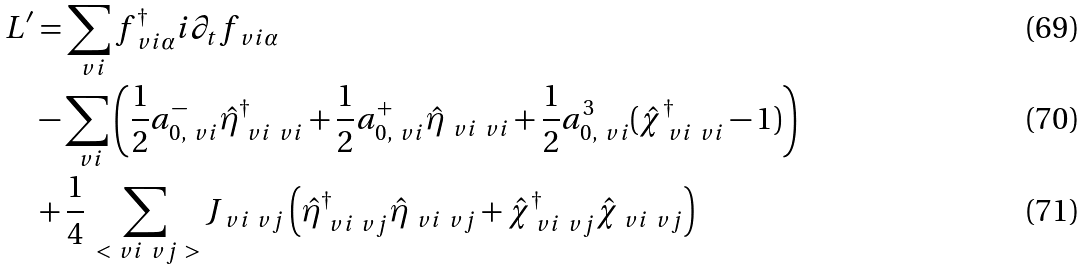Convert formula to latex. <formula><loc_0><loc_0><loc_500><loc_500>L ^ { \prime } & = \sum _ { \ v i } f _ { \ v i \alpha } ^ { \dagger } i \partial _ { t } f _ { \ v i \alpha } \\ & - \sum _ { \ v i } \left ( \frac { 1 } { 2 } a _ { 0 , \ v i } ^ { - } \hat { \eta } _ { \ v i \ v i } ^ { \dagger } + \frac { 1 } { 2 } a _ { 0 , \ v i } ^ { + } \hat { \eta } _ { \ v i \ v i } + \frac { 1 } { 2 } a _ { 0 , \ v i } ^ { 3 } ( \hat { \chi } _ { \ v i \ v i } ^ { \dagger } - 1 ) \right ) \\ & + \frac { 1 } { 4 } \sum _ { \ < \ v i \ v j \ > } J _ { \ v i \ v j } \left ( \hat { \eta } _ { \ v i \ v j } ^ { \dagger } \hat { \eta } _ { \ v i \ v j } + \hat { \chi } _ { \ v i \ v j } ^ { \dagger } \hat { \chi } _ { \ v i \ v j } \right )</formula> 